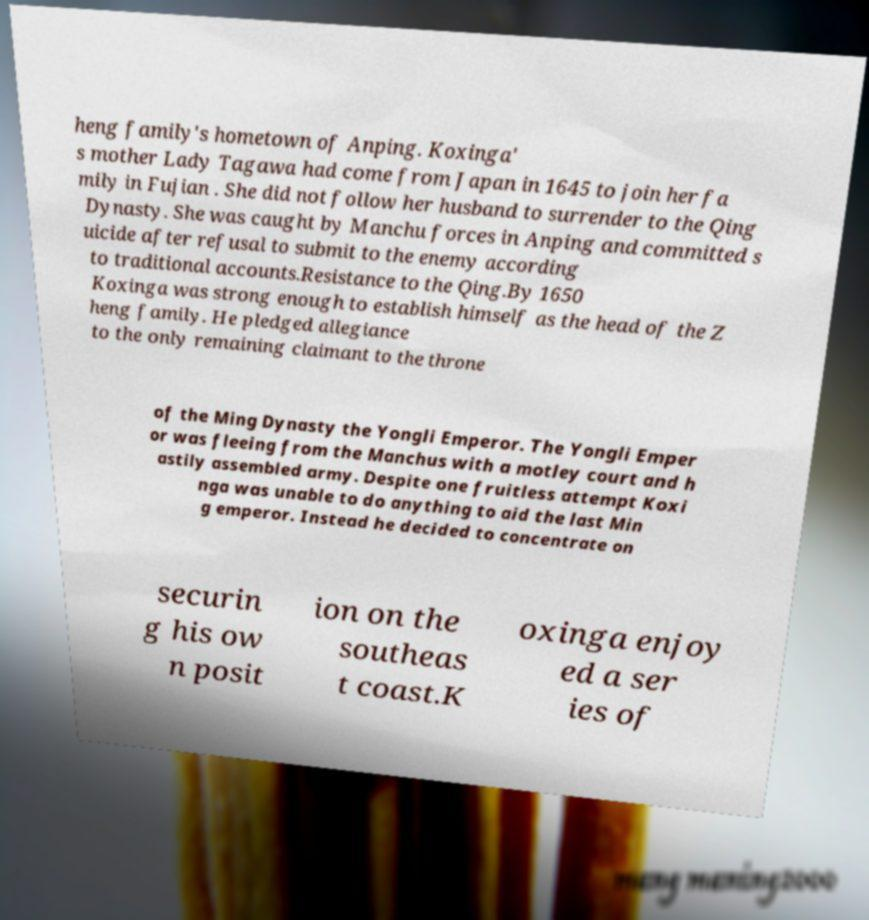Can you accurately transcribe the text from the provided image for me? heng family's hometown of Anping. Koxinga' s mother Lady Tagawa had come from Japan in 1645 to join her fa mily in Fujian . She did not follow her husband to surrender to the Qing Dynasty. She was caught by Manchu forces in Anping and committed s uicide after refusal to submit to the enemy according to traditional accounts.Resistance to the Qing.By 1650 Koxinga was strong enough to establish himself as the head of the Z heng family. He pledged allegiance to the only remaining claimant to the throne of the Ming Dynasty the Yongli Emperor. The Yongli Emper or was fleeing from the Manchus with a motley court and h astily assembled army. Despite one fruitless attempt Koxi nga was unable to do anything to aid the last Min g emperor. Instead he decided to concentrate on securin g his ow n posit ion on the southeas t coast.K oxinga enjoy ed a ser ies of 